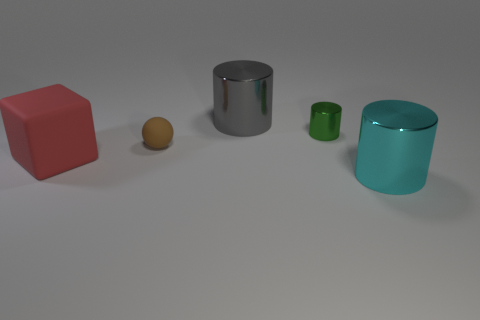There is a thing that is both behind the large rubber object and in front of the green thing; how big is it?
Provide a succinct answer. Small. What number of shiny cylinders are there?
Your response must be concise. 3. Are there fewer matte spheres than shiny objects?
Your answer should be compact. Yes. There is a cylinder that is the same size as the ball; what is its material?
Provide a short and direct response. Metal. How many objects are either cyan shiny cylinders or shiny things?
Provide a succinct answer. 3. How many metallic objects are both in front of the green cylinder and left of the green thing?
Your response must be concise. 0. Are there fewer large red things on the left side of the big cube than blue rubber cylinders?
Give a very brief answer. No. What shape is the cyan shiny object that is the same size as the gray cylinder?
Keep it short and to the point. Cylinder. Do the ball and the cyan object have the same size?
Your answer should be very brief. No. How many things are small green metallic things or rubber things to the right of the large red rubber thing?
Your answer should be compact. 2. 